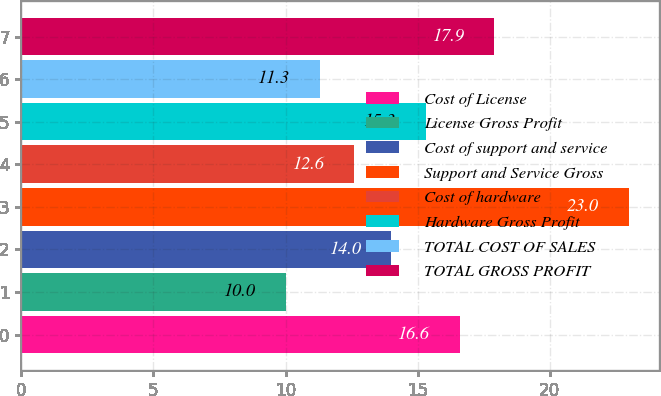<chart> <loc_0><loc_0><loc_500><loc_500><bar_chart><fcel>Cost of License<fcel>License Gross Profit<fcel>Cost of support and service<fcel>Support and Service Gross<fcel>Cost of hardware<fcel>Hardware Gross Profit<fcel>TOTAL COST OF SALES<fcel>TOTAL GROSS PROFIT<nl><fcel>16.6<fcel>10<fcel>14<fcel>23<fcel>12.6<fcel>15.3<fcel>11.3<fcel>17.9<nl></chart> 